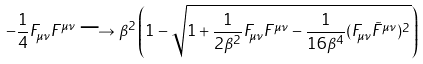Convert formula to latex. <formula><loc_0><loc_0><loc_500><loc_500>- \frac { 1 } { 4 } F _ { \mu \nu } F ^ { \mu \nu } \longrightarrow \beta ^ { 2 } \left ( 1 - \sqrt { 1 + \frac { 1 } { 2 \beta ^ { 2 } } F _ { \mu \nu } F ^ { \mu \nu } - \frac { 1 } { 1 6 \beta ^ { 4 } } ( F _ { \mu \nu } \tilde { F } ^ { \mu \nu } ) ^ { 2 } } \right )</formula> 